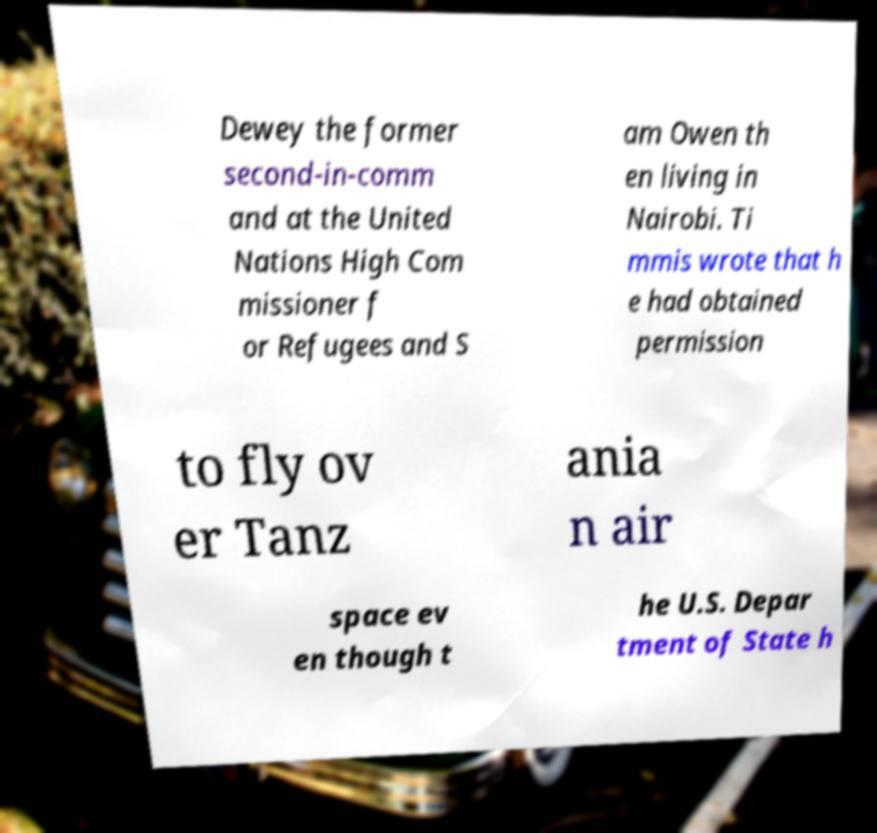Can you read and provide the text displayed in the image?This photo seems to have some interesting text. Can you extract and type it out for me? Dewey the former second-in-comm and at the United Nations High Com missioner f or Refugees and S am Owen th en living in Nairobi. Ti mmis wrote that h e had obtained permission to fly ov er Tanz ania n air space ev en though t he U.S. Depar tment of State h 